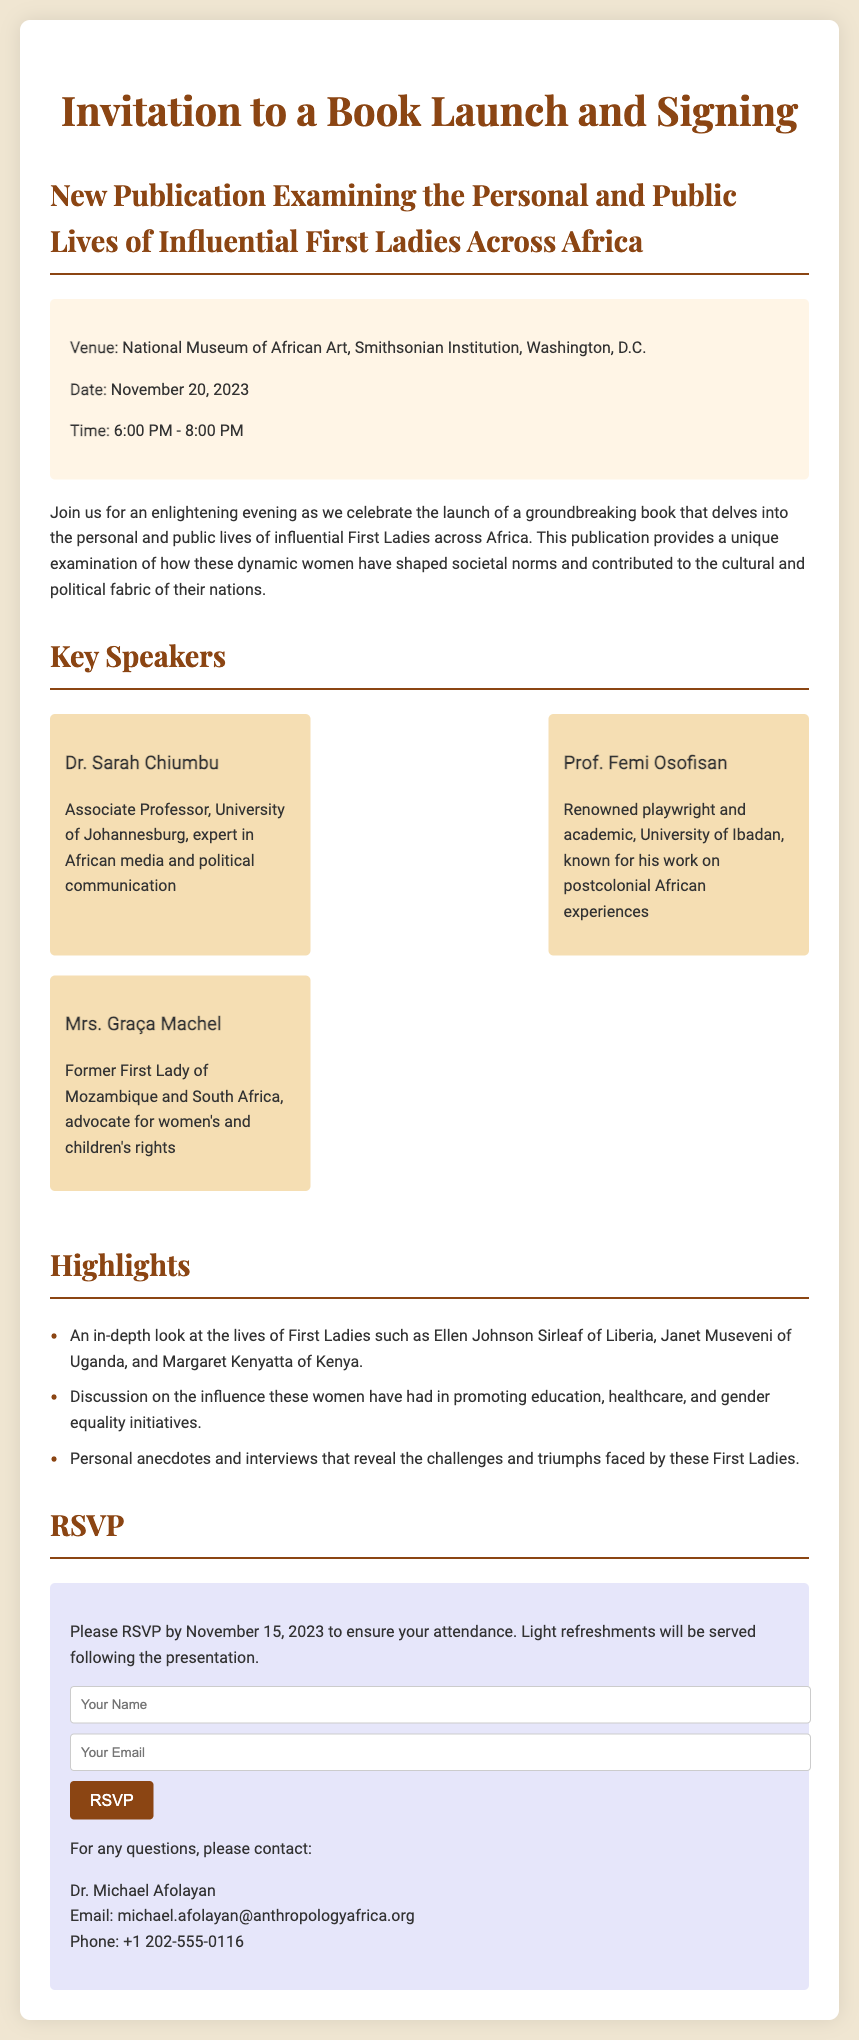What is the venue for the book launch? The venue is cited in the event details section.
Answer: National Museum of African Art, Smithsonian Institution, Washington, D.C What time does the event start? The start time is mentioned in the event details.
Answer: 6:00 PM Who is one of the key speakers? The document lists key speakers and their titles.
Answer: Dr. Sarah Chiumbu What date is the RSVP deadline? The RSVP deadline is clearly stated in the RSVP section.
Answer: November 15, 2023 What theme does the book explore? The introductory paragraph summarizes the book's central theme.
Answer: Personal and public lives of influential First Ladies across Africa How many speakers are mentioned in the document? The document lists three speakers in the speakers section.
Answer: Three What kind of refreshments will be served? The information about refreshments is found in the RSVP section.
Answer: Light refreshments Who can be contacted for questions? The contact information for inquiries is provided in the last section.
Answer: Dr. Michael Afolayan 